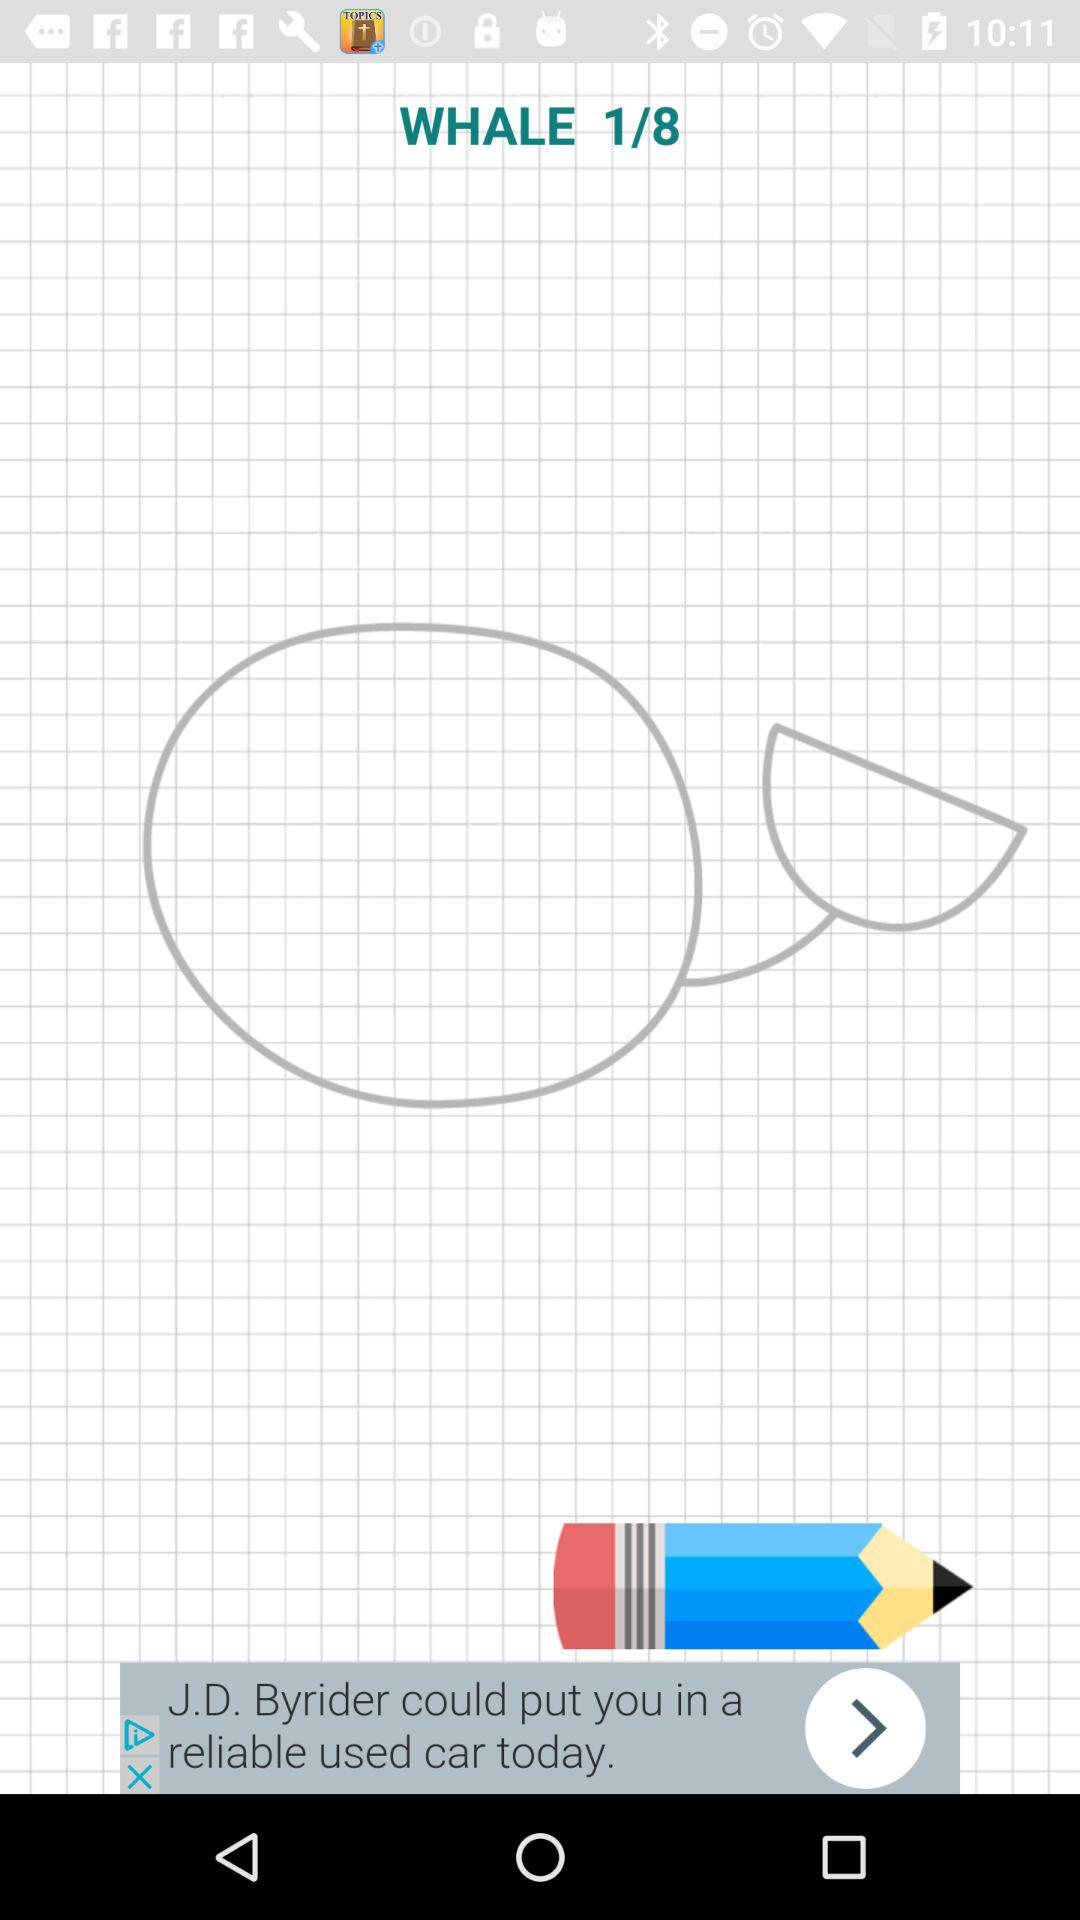How many total images are there? The total image is 8. 